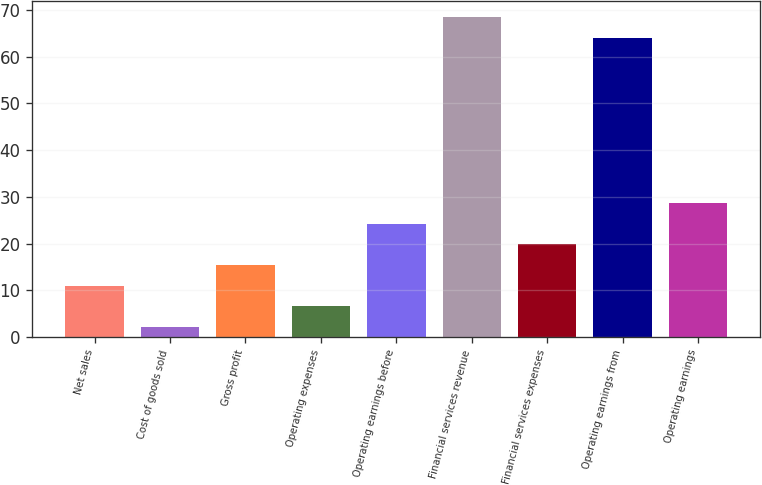<chart> <loc_0><loc_0><loc_500><loc_500><bar_chart><fcel>Net sales<fcel>Cost of goods sold<fcel>Gross profit<fcel>Operating expenses<fcel>Operating earnings before<fcel>Financial services revenue<fcel>Financial services expenses<fcel>Operating earnings from<fcel>Operating earnings<nl><fcel>10.96<fcel>2.1<fcel>15.39<fcel>6.53<fcel>24.25<fcel>68.55<fcel>19.82<fcel>64.12<fcel>28.68<nl></chart> 